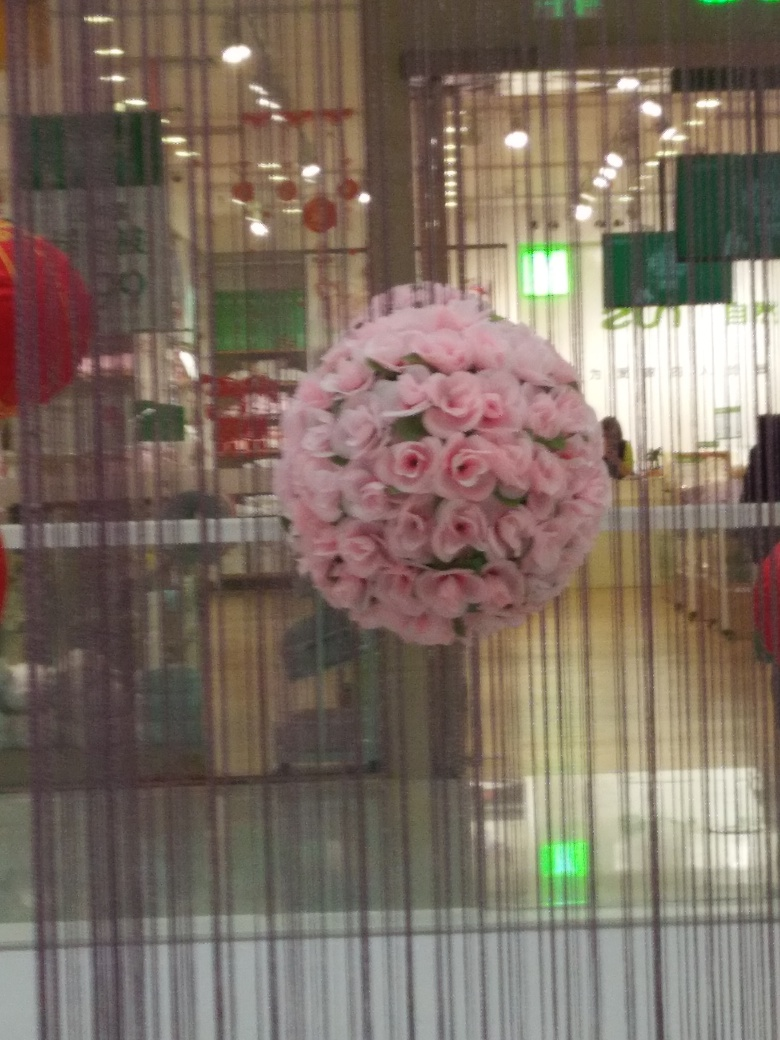Can you tell me more about the setting of this image? The image shows an indoor space with modern decor. The visible glass panes and vertical lines suggest a contemporary design, possibly in a shopping mall or a store. There's also Chinese lantern décor indicating a celebration or the presence of a cultural or festive event. 